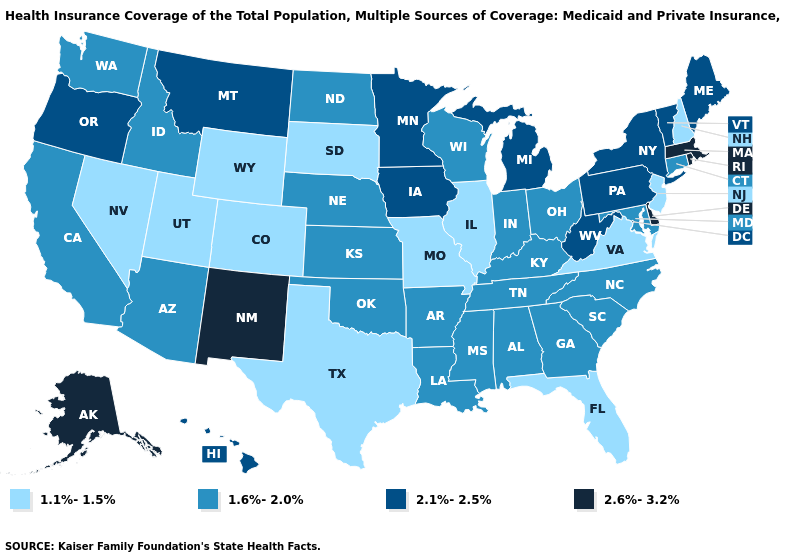Is the legend a continuous bar?
Write a very short answer. No. What is the lowest value in states that border Oregon?
Concise answer only. 1.1%-1.5%. What is the highest value in the USA?
Keep it brief. 2.6%-3.2%. Name the states that have a value in the range 1.1%-1.5%?
Be succinct. Colorado, Florida, Illinois, Missouri, Nevada, New Hampshire, New Jersey, South Dakota, Texas, Utah, Virginia, Wyoming. Name the states that have a value in the range 1.1%-1.5%?
Keep it brief. Colorado, Florida, Illinois, Missouri, Nevada, New Hampshire, New Jersey, South Dakota, Texas, Utah, Virginia, Wyoming. Name the states that have a value in the range 2.1%-2.5%?
Write a very short answer. Hawaii, Iowa, Maine, Michigan, Minnesota, Montana, New York, Oregon, Pennsylvania, Vermont, West Virginia. Does Virginia have the lowest value in the South?
Be succinct. Yes. Does Texas have the lowest value in the South?
Short answer required. Yes. How many symbols are there in the legend?
Keep it brief. 4. Among the states that border Florida , which have the highest value?
Write a very short answer. Alabama, Georgia. What is the lowest value in states that border Montana?
Answer briefly. 1.1%-1.5%. Does Alaska have the highest value in the USA?
Write a very short answer. Yes. Among the states that border Alabama , which have the highest value?
Keep it brief. Georgia, Mississippi, Tennessee. Which states have the lowest value in the MidWest?
Short answer required. Illinois, Missouri, South Dakota. 